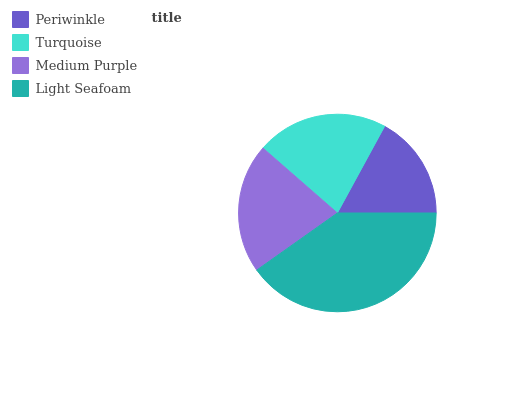Is Periwinkle the minimum?
Answer yes or no. Yes. Is Light Seafoam the maximum?
Answer yes or no. Yes. Is Turquoise the minimum?
Answer yes or no. No. Is Turquoise the maximum?
Answer yes or no. No. Is Turquoise greater than Periwinkle?
Answer yes or no. Yes. Is Periwinkle less than Turquoise?
Answer yes or no. Yes. Is Periwinkle greater than Turquoise?
Answer yes or no. No. Is Turquoise less than Periwinkle?
Answer yes or no. No. Is Turquoise the high median?
Answer yes or no. Yes. Is Medium Purple the low median?
Answer yes or no. Yes. Is Light Seafoam the high median?
Answer yes or no. No. Is Turquoise the low median?
Answer yes or no. No. 